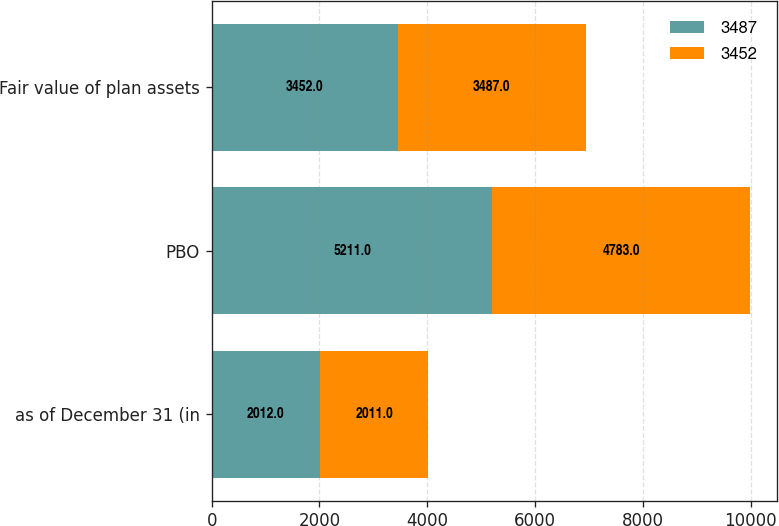<chart> <loc_0><loc_0><loc_500><loc_500><stacked_bar_chart><ecel><fcel>as of December 31 (in<fcel>PBO<fcel>Fair value of plan assets<nl><fcel>3487<fcel>2012<fcel>5211<fcel>3452<nl><fcel>3452<fcel>2011<fcel>4783<fcel>3487<nl></chart> 